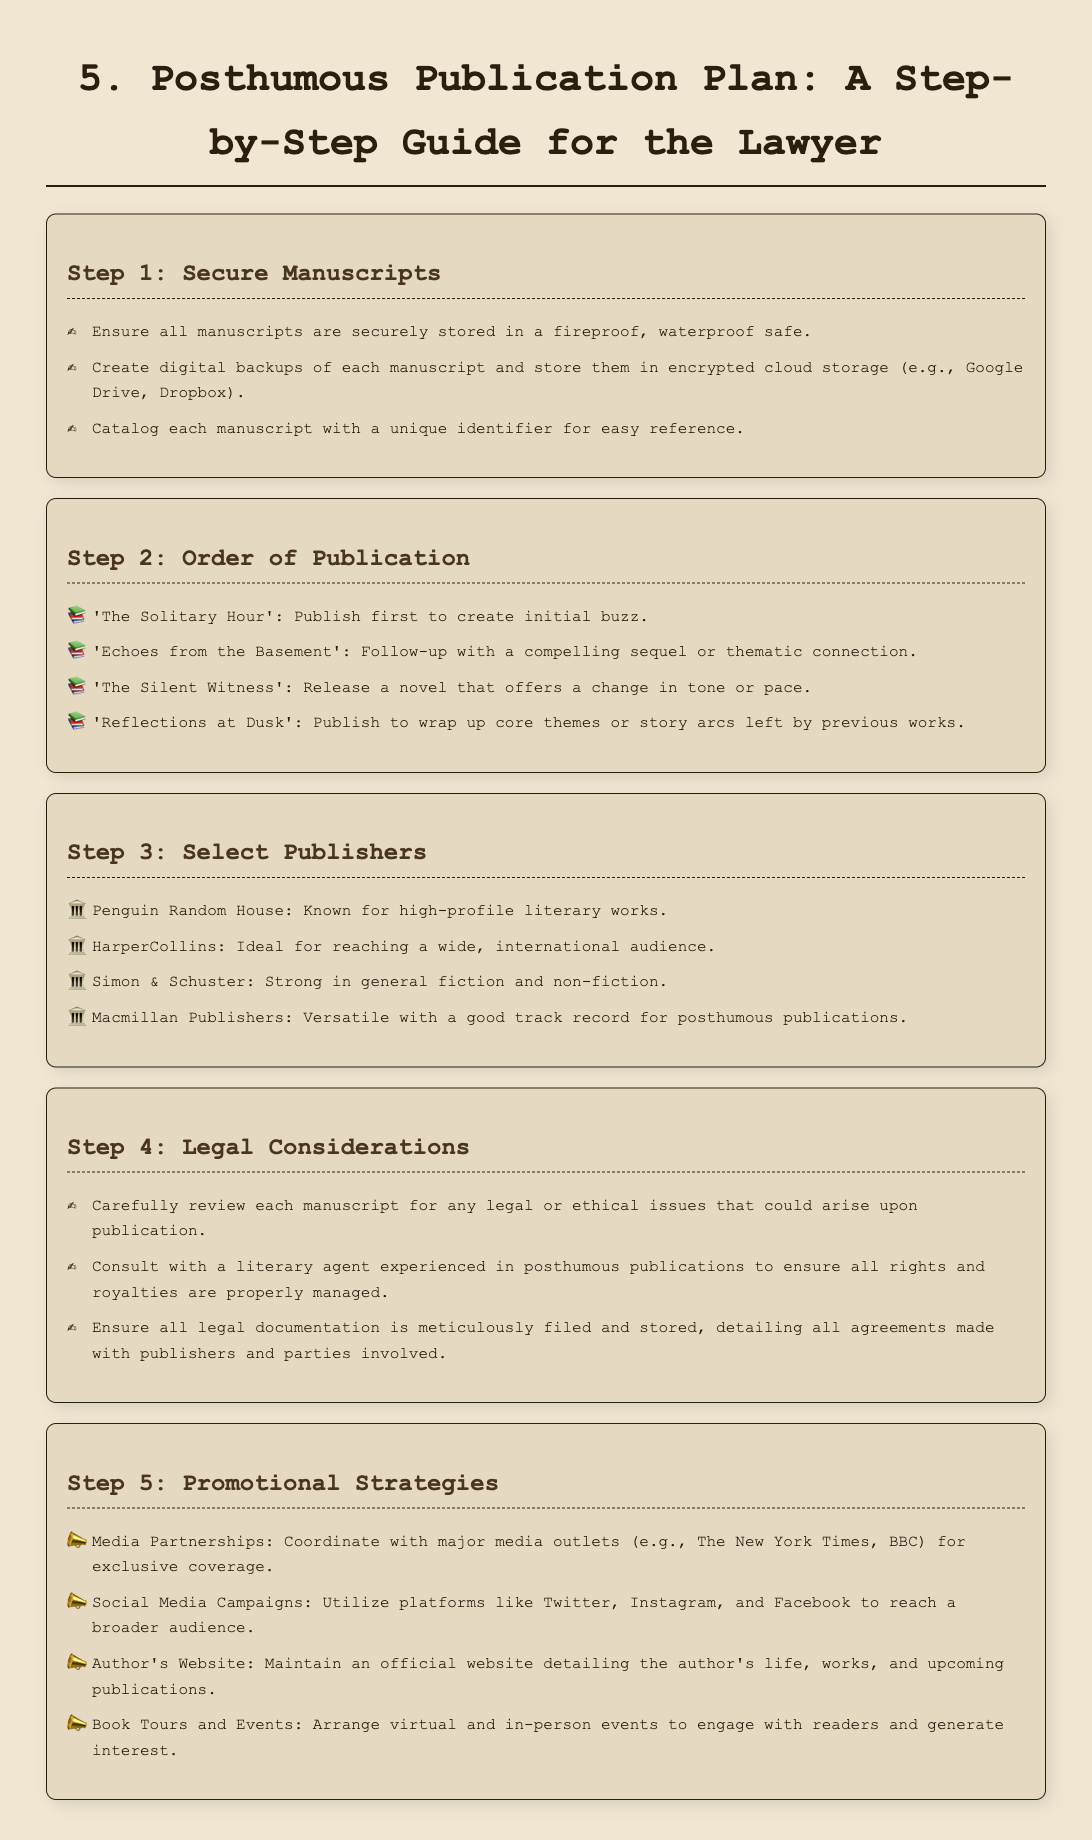What is the first manuscript to be published? The document states that 'The Solitary Hour' is the first manuscript planned for publication to create initial buzz.
Answer: 'The Solitary Hour' How many publishers are listed in the document? The document mentions four publishers that are suitable for posthumous publications.
Answer: 4 What should be done with manuscripts before publication? The first step includes ensuring all manuscripts are securely stored in a fireproof, waterproof safe.
Answer: Securely stored Which publisher is known for high-profile literary works? The document identifies Penguin Random House as known for high-profile literary works.
Answer: Penguin Random House What is one promotional strategy mentioned in the document? The document suggests utilizing social media campaigns as one of the promotional strategies for the posthumous publications.
Answer: Social Media Campaigns What is the title of the second manuscript in the publication order? The title following 'The Solitary Hour' for publication is 'Echoes from the Basement'.
Answer: 'Echoes from the Basement' Who should be consulted regarding legal issues? The document advises consulting a literary agent experienced in posthumous publications for handling legal considerations.
Answer: Literary agent What type of events are suggested for engaging readers? The document describes arranging book tours and events as a strategy to engage with readers.
Answer: Book Tours and Events 